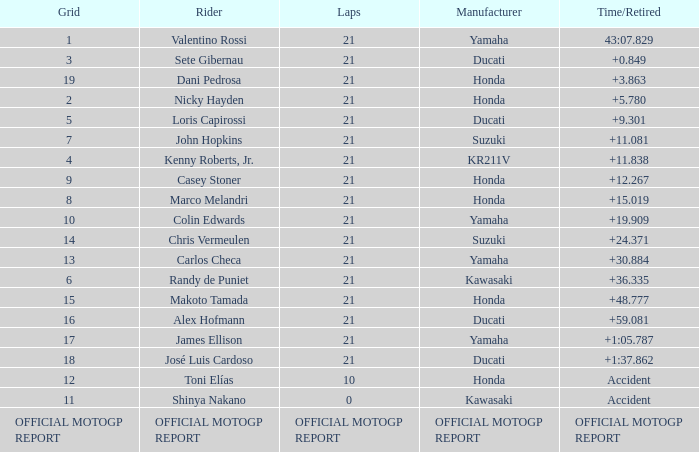How many laps did Valentino rossi have when riding a vehicle manufactured by yamaha? 21.0. 